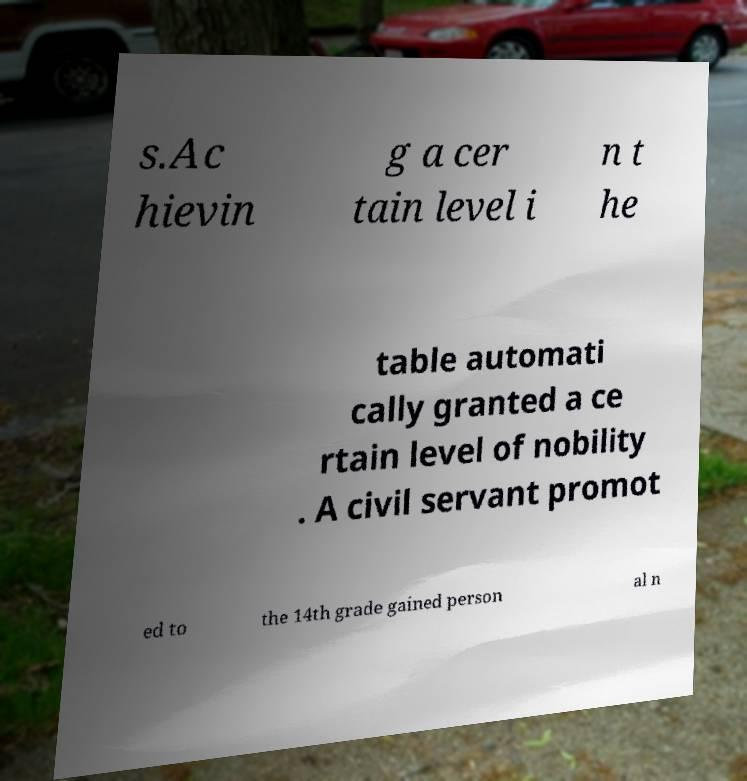Could you extract and type out the text from this image? s.Ac hievin g a cer tain level i n t he table automati cally granted a ce rtain level of nobility . A civil servant promot ed to the 14th grade gained person al n 